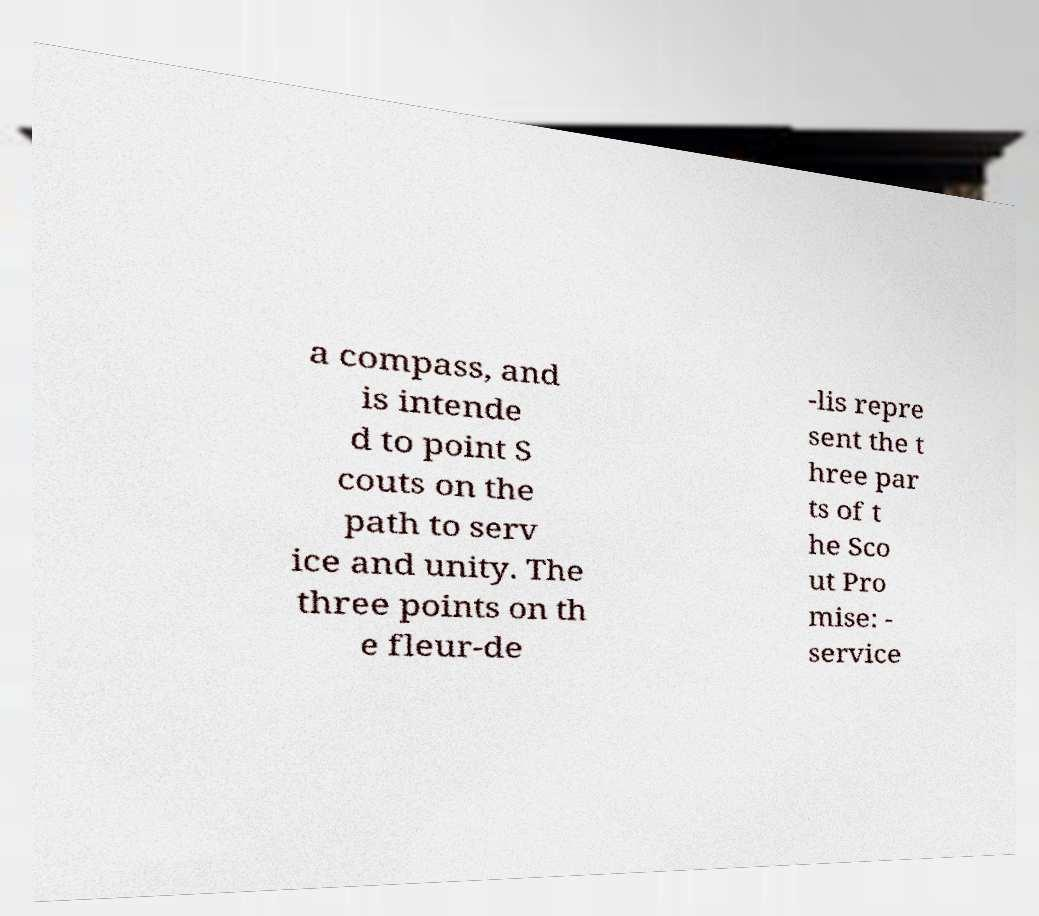For documentation purposes, I need the text within this image transcribed. Could you provide that? a compass, and is intende d to point S couts on the path to serv ice and unity. The three points on th e fleur-de -lis repre sent the t hree par ts of t he Sco ut Pro mise: - service 